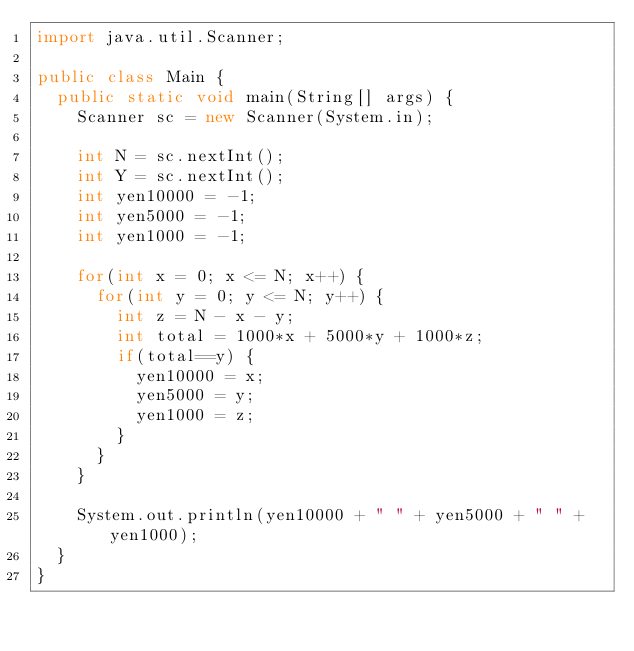Convert code to text. <code><loc_0><loc_0><loc_500><loc_500><_Java_>import java.util.Scanner;

public class Main {
	public static void main(String[] args) {
		Scanner sc = new Scanner(System.in);

		int N = sc.nextInt();
		int Y = sc.nextInt();
		int yen10000 = -1;
		int yen5000 = -1;
		int yen1000 = -1;

		for(int x = 0; x <= N; x++) {
			for(int y = 0; y <= N; y++) {
				int z = N - x - y;
				int total = 1000*x + 5000*y + 1000*z;
				if(total==y) {
					yen10000 = x;
					yen5000 = y;
					yen1000 = z;
				}
			}
		}

		System.out.println(yen10000 + " " + yen5000 + " " + yen1000);
	}
}
</code> 